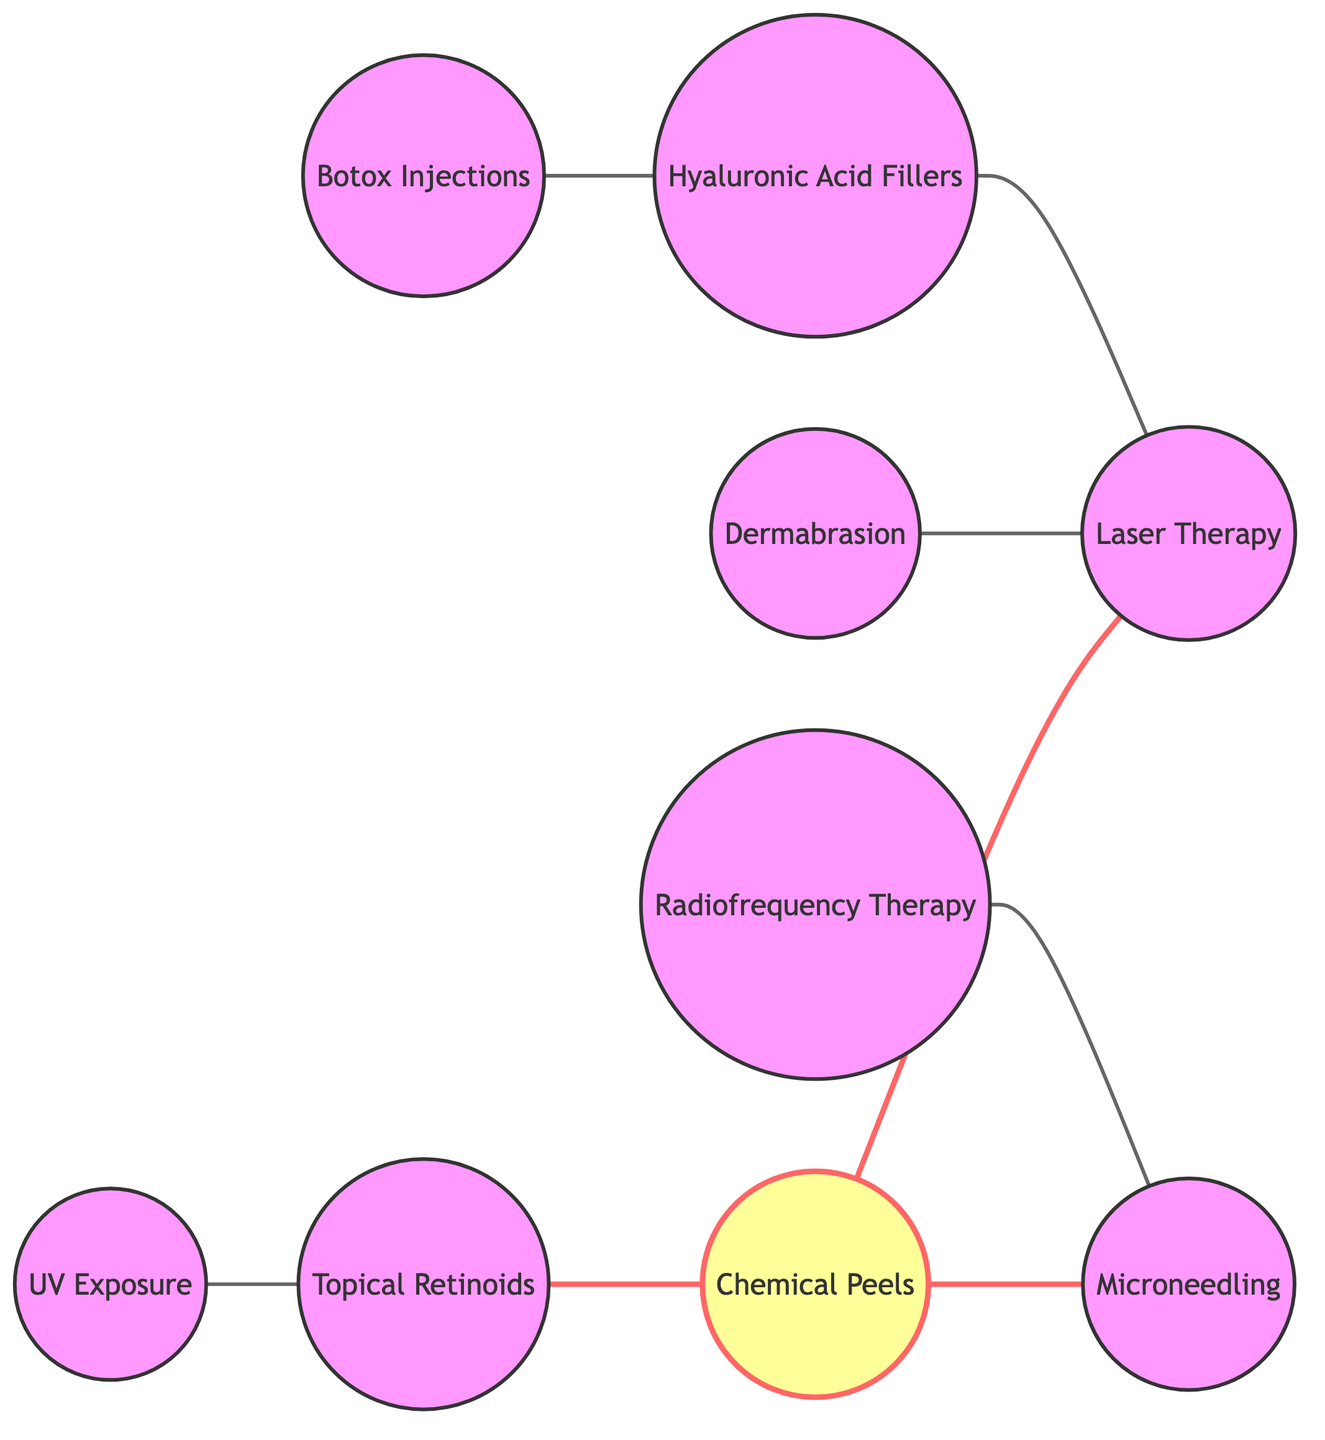What is the total number of nodes in the diagram? The diagram lists eight distinct treatment options represented as nodes. These nodes are Chemical Peels, Laser Therapy, Microneedling, Dermabrasion, Radiofrequency Therapy, Topical Retinoids, Botox Injections, and Hyaluronic Acid Fillers, and UV Exposure. Counting these gives a total of eight nodes.
Answer: 8 Which two treatments are linked by the label "Effectiveness Comparison"? In the diagram, the node for Chemical Peels is directly connected to the node for Laser Therapy with a link that is labeled "Effectiveness Comparison." This indicates a comparison aspect between these two specific treatments.
Answer: Chemical Peels and Laser Therapy How many links are associated with "Microneedling"? The node representing Microneedling has two connections: one with Chemical Peels (labeled "Invasiveness Comparison") and another with Radiofrequency Therapy (labeled "Combination Therapy"). Counting these gives a total of two links associated with Microneedling.
Answer: 2 What is the relationship label between "Topical Retinoids" and "Chemical Peels"? The diagram shows that the relationship between Topical Retinoids and Chemical Peels is represented by the connection labeled "Adjunctive Use." This indicates that these treatments are used complementarily in some contexts.
Answer: Adjunctive Use Which treatment is related to "Radiofrequency Therapy" concerning combination approaches? The Microneedling treatment is linked to Radiofrequency Therapy with the label "Combination Therapy." This implies that both techniques may be used together for enhanced effects.
Answer: Microneedling Which two treatments are indicated as "Complementary Treatments"? In the graph, there is a direct link between Botox Injections and Hyaluronic Acid Fillers labeled as "Complementary Treatments." This signifies that these treatments work well together in practice.
Answer: Botox Injections and Hyaluronic Acid Fillers Is there a connection between "UV Exposure" and "Topical Retinoids"? If yes, what is the label? Yes, there is a connection between UV Exposure and Topical Retinoids. The link is labeled "Prevention vs Treatment," indicating that these treatments relate to their roles in either preventing skin damage or treating it.
Answer: Prevention vs Treatment How many different treatment options are connected to "Laser Therapy"? Laser Therapy is connected to three different treatment options: Chemical Peels (effectiveness comparison), Dermabrasion (recovery time), and Hyaluronic Acid Fillers (synergistic effects). Therefore, counting these connections gives a total of three connected treatment options.
Answer: 3 